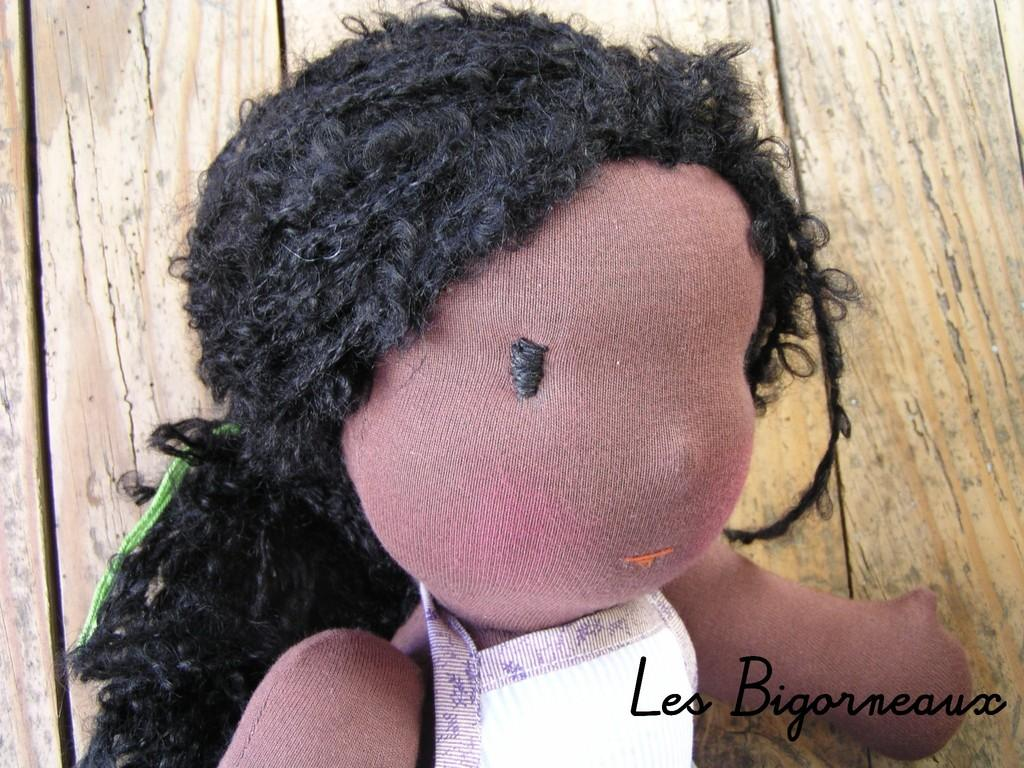What is the main subject of the image? There is a doll in the image. What type of humor does the bear use to increase its profit in the image? There is no bear or mention of humor or profit in the image; it only features a doll. 